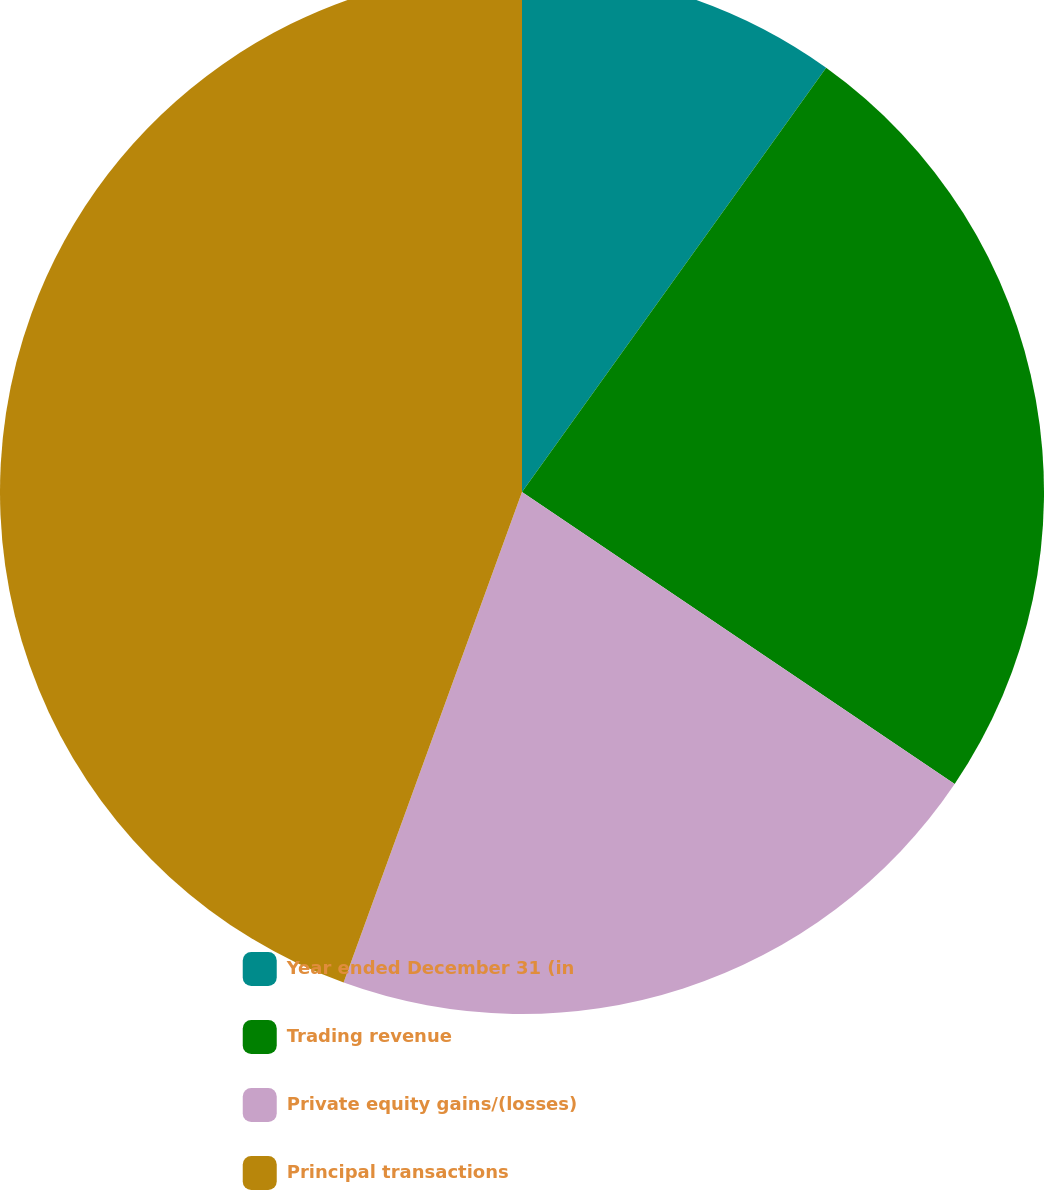Convert chart to OTSL. <chart><loc_0><loc_0><loc_500><loc_500><pie_chart><fcel>Year ended December 31 (in<fcel>Trading revenue<fcel>Private equity gains/(losses)<fcel>Principal transactions<nl><fcel>9.9%<fcel>24.55%<fcel>21.1%<fcel>44.45%<nl></chart> 